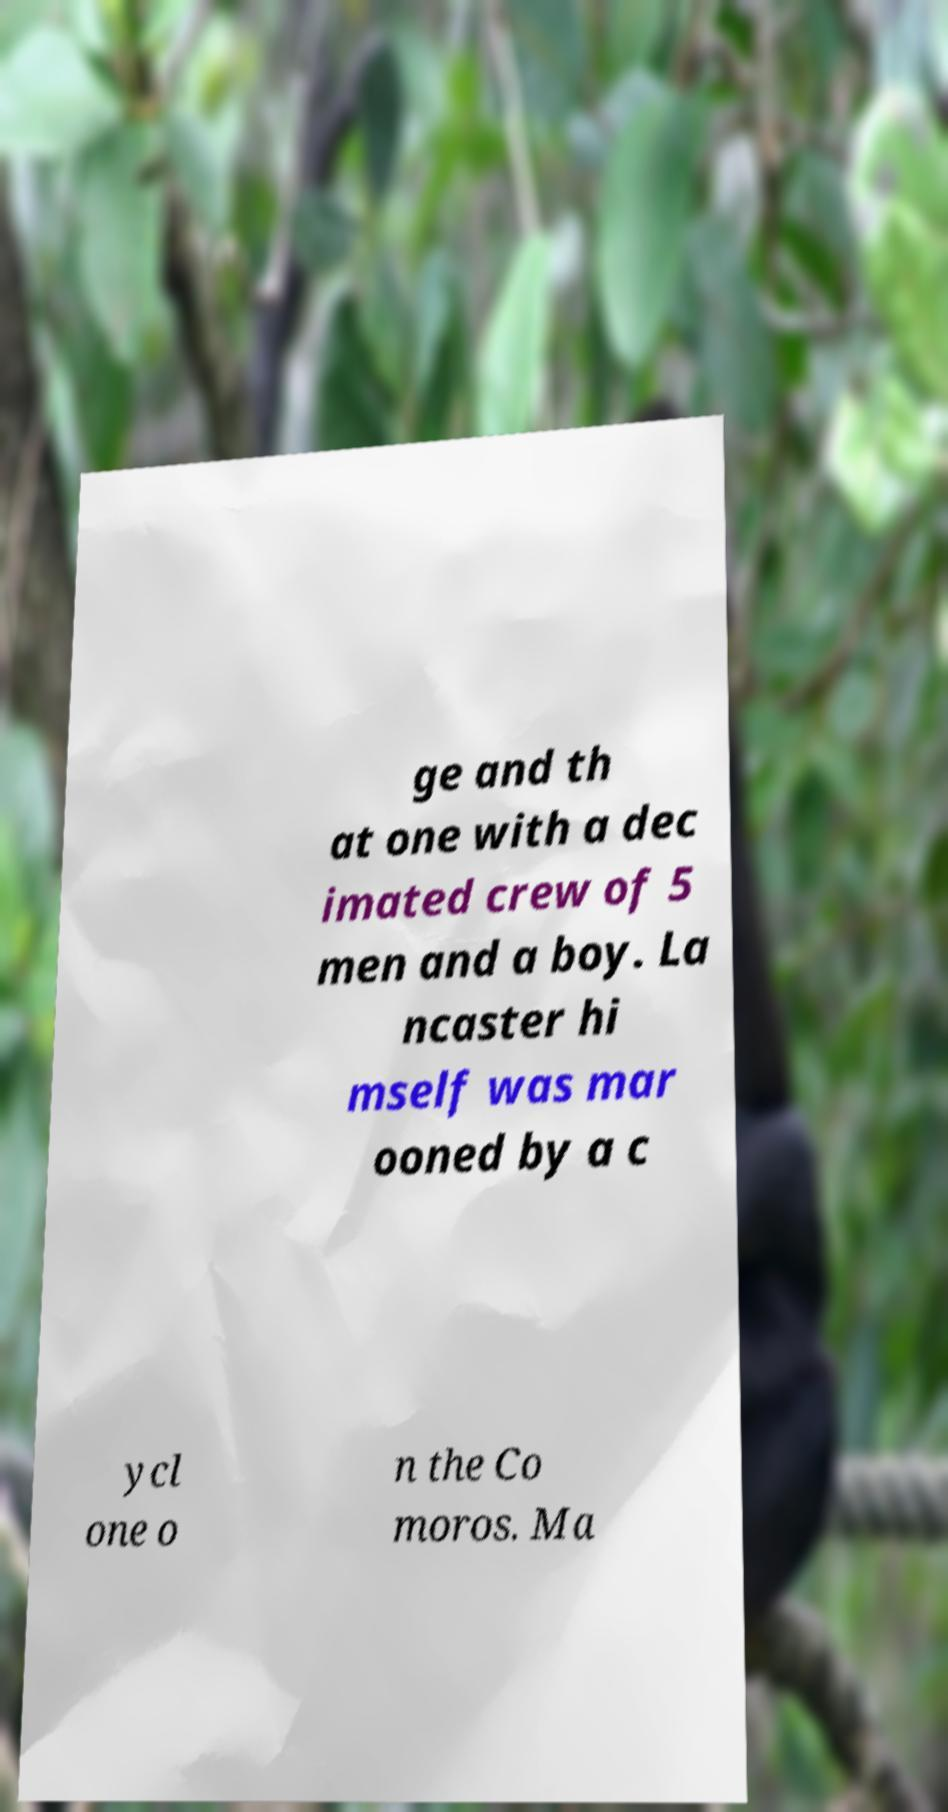For documentation purposes, I need the text within this image transcribed. Could you provide that? ge and th at one with a dec imated crew of 5 men and a boy. La ncaster hi mself was mar ooned by a c ycl one o n the Co moros. Ma 